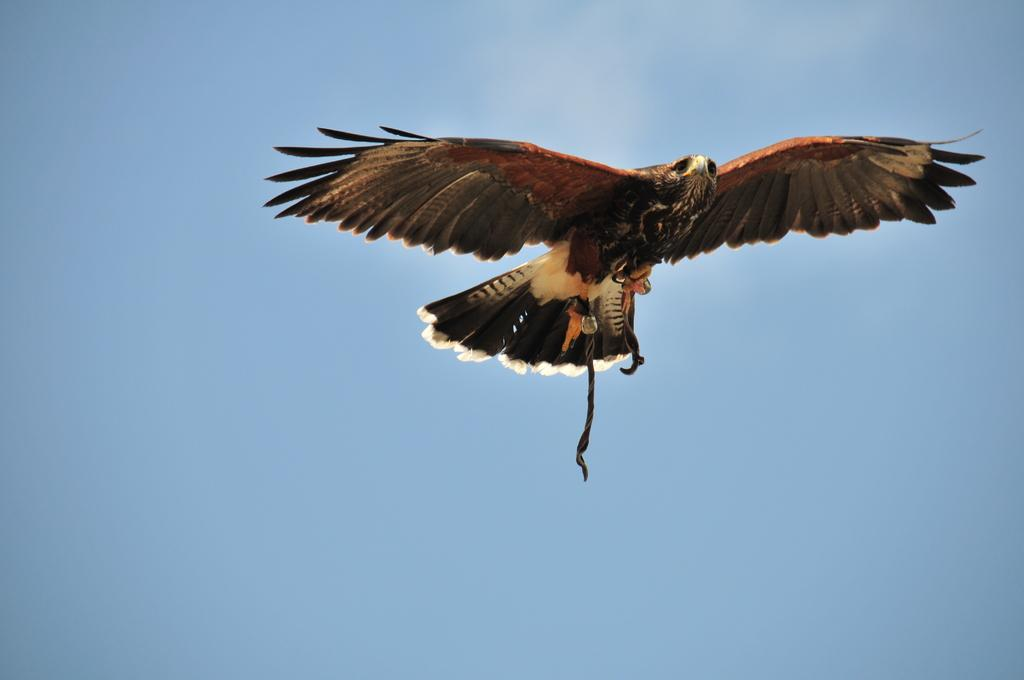What animal is in the foreground of the image? There is an eagle in the foreground of the image. What is the eagle doing in the image? The eagle is in the air. What can be seen in the background of the image? The sky is visible in the background of the image. Where is the seed that the aunt planted in the image? There is no seed or aunt mentioned in the image; it only features an eagle in the air. What type of tank is visible in the image? There is no tank present in the image; it only features an eagle in the air and the sky in the background. 